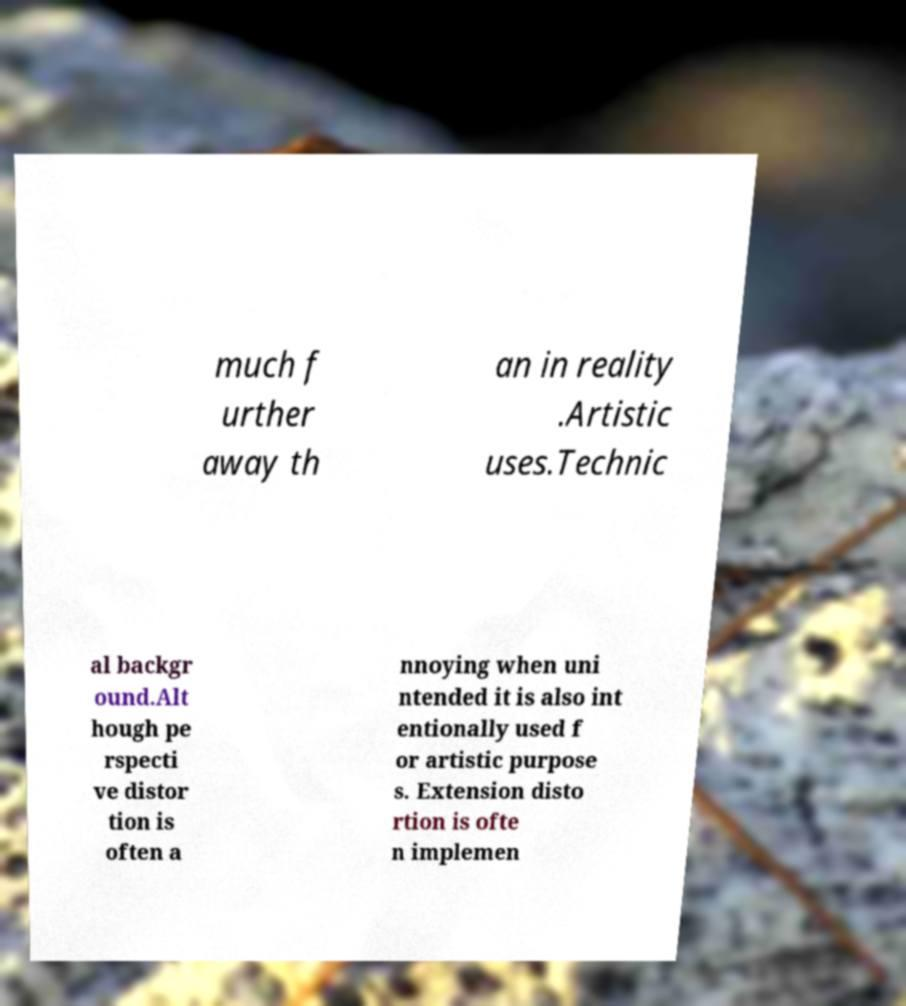Can you accurately transcribe the text from the provided image for me? much f urther away th an in reality .Artistic uses.Technic al backgr ound.Alt hough pe rspecti ve distor tion is often a nnoying when uni ntended it is also int entionally used f or artistic purpose s. Extension disto rtion is ofte n implemen 